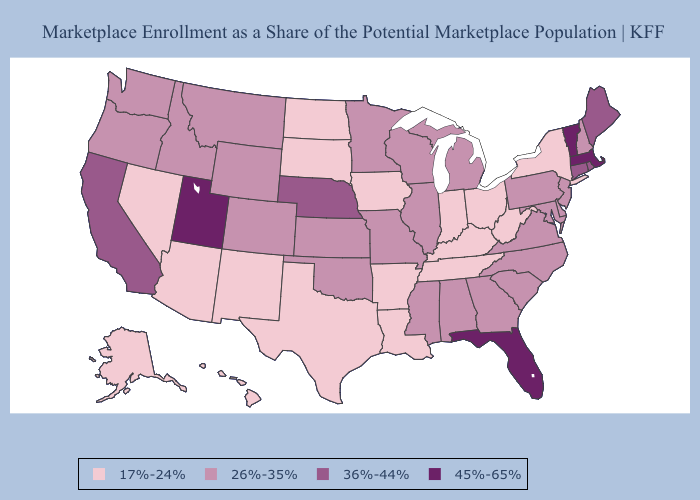Does Michigan have the lowest value in the USA?
Keep it brief. No. What is the highest value in states that border Alabama?
Give a very brief answer. 45%-65%. Name the states that have a value in the range 36%-44%?
Short answer required. California, Connecticut, Maine, Nebraska, Rhode Island. What is the highest value in the MidWest ?
Write a very short answer. 36%-44%. How many symbols are there in the legend?
Write a very short answer. 4. Among the states that border Texas , which have the highest value?
Write a very short answer. Oklahoma. Does Vermont have the lowest value in the USA?
Keep it brief. No. What is the lowest value in the South?
Be succinct. 17%-24%. Which states hav the highest value in the West?
Concise answer only. Utah. Does the first symbol in the legend represent the smallest category?
Concise answer only. Yes. Does the first symbol in the legend represent the smallest category?
Write a very short answer. Yes. What is the value of Louisiana?
Answer briefly. 17%-24%. Name the states that have a value in the range 17%-24%?
Quick response, please. Alaska, Arizona, Arkansas, Hawaii, Indiana, Iowa, Kentucky, Louisiana, Nevada, New Mexico, New York, North Dakota, Ohio, South Dakota, Tennessee, Texas, West Virginia. Which states hav the highest value in the Northeast?
Be succinct. Massachusetts, Vermont. 